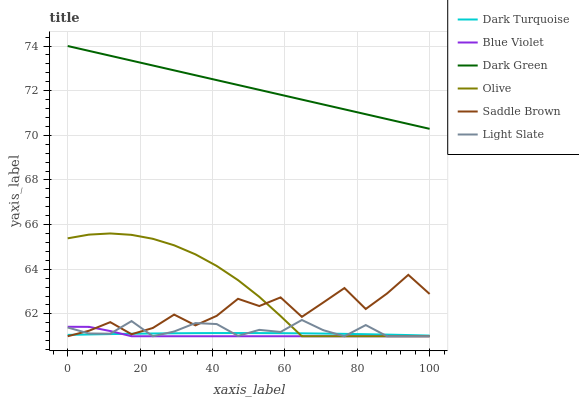Does Dark Turquoise have the minimum area under the curve?
Answer yes or no. No. Does Dark Turquoise have the maximum area under the curve?
Answer yes or no. No. Is Dark Turquoise the smoothest?
Answer yes or no. No. Is Dark Turquoise the roughest?
Answer yes or no. No. Does Dark Turquoise have the lowest value?
Answer yes or no. No. Does Olive have the highest value?
Answer yes or no. No. Is Dark Turquoise less than Dark Green?
Answer yes or no. Yes. Is Dark Green greater than Light Slate?
Answer yes or no. Yes. Does Dark Turquoise intersect Dark Green?
Answer yes or no. No. 